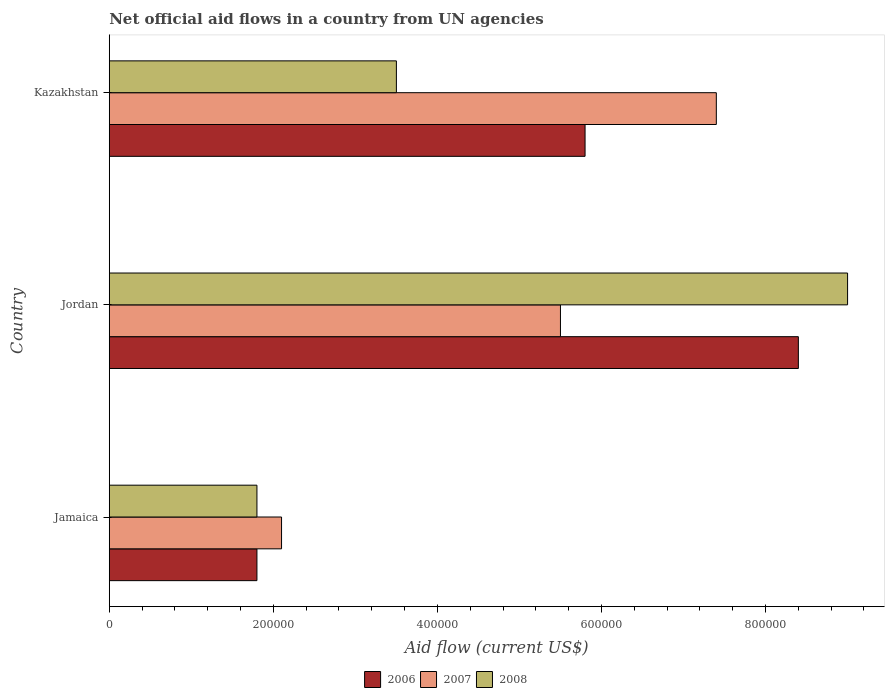How many groups of bars are there?
Keep it short and to the point. 3. Are the number of bars per tick equal to the number of legend labels?
Offer a very short reply. Yes. What is the label of the 2nd group of bars from the top?
Provide a succinct answer. Jordan. In how many cases, is the number of bars for a given country not equal to the number of legend labels?
Provide a succinct answer. 0. What is the net official aid flow in 2008 in Kazakhstan?
Offer a terse response. 3.50e+05. Across all countries, what is the maximum net official aid flow in 2007?
Offer a very short reply. 7.40e+05. In which country was the net official aid flow in 2008 maximum?
Offer a very short reply. Jordan. In which country was the net official aid flow in 2008 minimum?
Your answer should be very brief. Jamaica. What is the total net official aid flow in 2008 in the graph?
Your response must be concise. 1.43e+06. What is the difference between the net official aid flow in 2007 in Kazakhstan and the net official aid flow in 2008 in Jamaica?
Your answer should be very brief. 5.60e+05. What is the difference between the net official aid flow in 2006 and net official aid flow in 2008 in Jordan?
Give a very brief answer. -6.00e+04. What is the ratio of the net official aid flow in 2008 in Jordan to that in Kazakhstan?
Make the answer very short. 2.57. Is the difference between the net official aid flow in 2006 in Jamaica and Jordan greater than the difference between the net official aid flow in 2008 in Jamaica and Jordan?
Your answer should be compact. Yes. What is the difference between the highest and the lowest net official aid flow in 2007?
Provide a short and direct response. 5.30e+05. In how many countries, is the net official aid flow in 2007 greater than the average net official aid flow in 2007 taken over all countries?
Offer a terse response. 2. What does the 1st bar from the bottom in Jordan represents?
Provide a short and direct response. 2006. What is the difference between two consecutive major ticks on the X-axis?
Give a very brief answer. 2.00e+05. Does the graph contain any zero values?
Offer a terse response. No. Does the graph contain grids?
Offer a very short reply. No. What is the title of the graph?
Provide a succinct answer. Net official aid flows in a country from UN agencies. Does "1987" appear as one of the legend labels in the graph?
Provide a succinct answer. No. What is the label or title of the X-axis?
Give a very brief answer. Aid flow (current US$). What is the label or title of the Y-axis?
Keep it short and to the point. Country. What is the Aid flow (current US$) of 2008 in Jamaica?
Ensure brevity in your answer.  1.80e+05. What is the Aid flow (current US$) of 2006 in Jordan?
Give a very brief answer. 8.40e+05. What is the Aid flow (current US$) in 2008 in Jordan?
Your answer should be very brief. 9.00e+05. What is the Aid flow (current US$) in 2006 in Kazakhstan?
Your answer should be compact. 5.80e+05. What is the Aid flow (current US$) of 2007 in Kazakhstan?
Give a very brief answer. 7.40e+05. What is the Aid flow (current US$) in 2008 in Kazakhstan?
Provide a short and direct response. 3.50e+05. Across all countries, what is the maximum Aid flow (current US$) of 2006?
Offer a very short reply. 8.40e+05. Across all countries, what is the maximum Aid flow (current US$) in 2007?
Provide a short and direct response. 7.40e+05. Across all countries, what is the minimum Aid flow (current US$) of 2006?
Your answer should be very brief. 1.80e+05. Across all countries, what is the minimum Aid flow (current US$) of 2008?
Keep it short and to the point. 1.80e+05. What is the total Aid flow (current US$) of 2006 in the graph?
Provide a short and direct response. 1.60e+06. What is the total Aid flow (current US$) of 2007 in the graph?
Keep it short and to the point. 1.50e+06. What is the total Aid flow (current US$) of 2008 in the graph?
Your response must be concise. 1.43e+06. What is the difference between the Aid flow (current US$) of 2006 in Jamaica and that in Jordan?
Make the answer very short. -6.60e+05. What is the difference between the Aid flow (current US$) of 2008 in Jamaica and that in Jordan?
Make the answer very short. -7.20e+05. What is the difference between the Aid flow (current US$) of 2006 in Jamaica and that in Kazakhstan?
Your response must be concise. -4.00e+05. What is the difference between the Aid flow (current US$) in 2007 in Jamaica and that in Kazakhstan?
Make the answer very short. -5.30e+05. What is the difference between the Aid flow (current US$) of 2006 in Jamaica and the Aid flow (current US$) of 2007 in Jordan?
Ensure brevity in your answer.  -3.70e+05. What is the difference between the Aid flow (current US$) in 2006 in Jamaica and the Aid flow (current US$) in 2008 in Jordan?
Make the answer very short. -7.20e+05. What is the difference between the Aid flow (current US$) of 2007 in Jamaica and the Aid flow (current US$) of 2008 in Jordan?
Offer a very short reply. -6.90e+05. What is the difference between the Aid flow (current US$) in 2006 in Jamaica and the Aid flow (current US$) in 2007 in Kazakhstan?
Your response must be concise. -5.60e+05. What is the difference between the Aid flow (current US$) of 2007 in Jamaica and the Aid flow (current US$) of 2008 in Kazakhstan?
Keep it short and to the point. -1.40e+05. What is the difference between the Aid flow (current US$) of 2006 in Jordan and the Aid flow (current US$) of 2008 in Kazakhstan?
Your response must be concise. 4.90e+05. What is the difference between the Aid flow (current US$) in 2007 in Jordan and the Aid flow (current US$) in 2008 in Kazakhstan?
Make the answer very short. 2.00e+05. What is the average Aid flow (current US$) of 2006 per country?
Your answer should be compact. 5.33e+05. What is the average Aid flow (current US$) in 2007 per country?
Keep it short and to the point. 5.00e+05. What is the average Aid flow (current US$) in 2008 per country?
Your answer should be compact. 4.77e+05. What is the difference between the Aid flow (current US$) in 2006 and Aid flow (current US$) in 2008 in Jordan?
Provide a short and direct response. -6.00e+04. What is the difference between the Aid flow (current US$) of 2007 and Aid flow (current US$) of 2008 in Jordan?
Your response must be concise. -3.50e+05. What is the difference between the Aid flow (current US$) in 2006 and Aid flow (current US$) in 2008 in Kazakhstan?
Your answer should be compact. 2.30e+05. What is the ratio of the Aid flow (current US$) in 2006 in Jamaica to that in Jordan?
Give a very brief answer. 0.21. What is the ratio of the Aid flow (current US$) in 2007 in Jamaica to that in Jordan?
Your answer should be very brief. 0.38. What is the ratio of the Aid flow (current US$) in 2008 in Jamaica to that in Jordan?
Make the answer very short. 0.2. What is the ratio of the Aid flow (current US$) of 2006 in Jamaica to that in Kazakhstan?
Offer a terse response. 0.31. What is the ratio of the Aid flow (current US$) of 2007 in Jamaica to that in Kazakhstan?
Provide a short and direct response. 0.28. What is the ratio of the Aid flow (current US$) in 2008 in Jamaica to that in Kazakhstan?
Keep it short and to the point. 0.51. What is the ratio of the Aid flow (current US$) in 2006 in Jordan to that in Kazakhstan?
Provide a succinct answer. 1.45. What is the ratio of the Aid flow (current US$) in 2007 in Jordan to that in Kazakhstan?
Ensure brevity in your answer.  0.74. What is the ratio of the Aid flow (current US$) of 2008 in Jordan to that in Kazakhstan?
Make the answer very short. 2.57. What is the difference between the highest and the lowest Aid flow (current US$) of 2007?
Make the answer very short. 5.30e+05. What is the difference between the highest and the lowest Aid flow (current US$) in 2008?
Your response must be concise. 7.20e+05. 